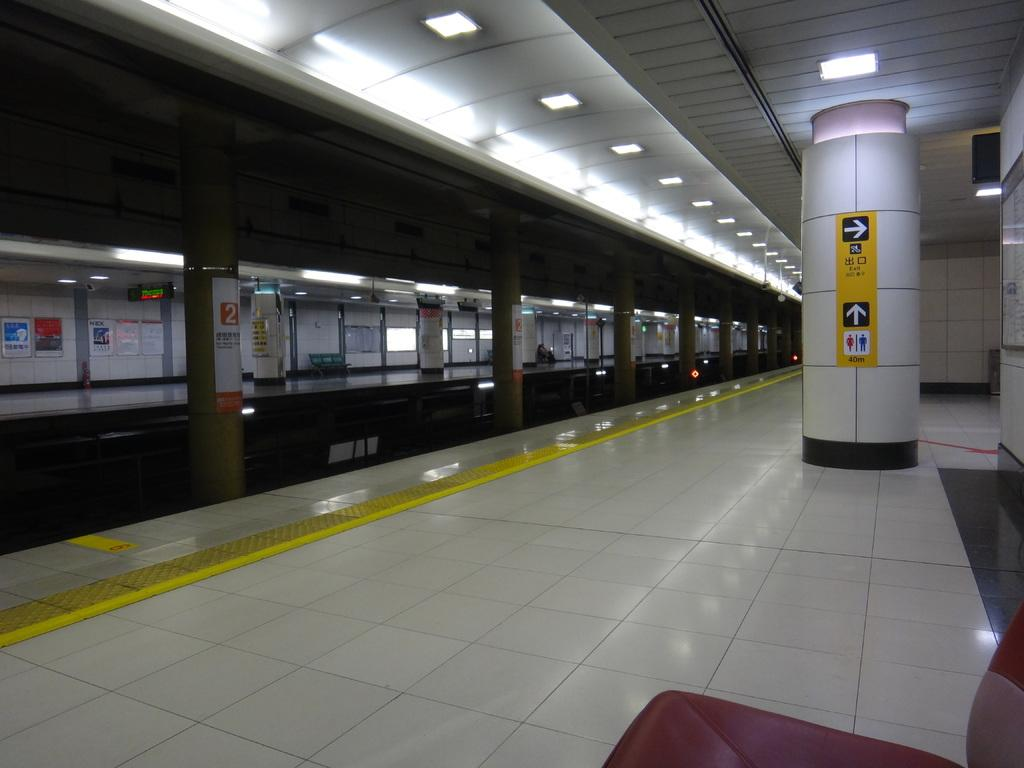What can be seen on the wall in the image? There are posters on the wall in the image. What architectural features are present in the image? There are pillars and poles in the image. What other objects can be seen in the image? There are boards and lights in the image. How much debt is represented by the posters on the wall in the image? There is no indication of debt in the image, as the posters are not related to financial matters. What color is the stomach of the person in the image? There is no person present in the image, so it is not possible to determine the color of their stomach. 